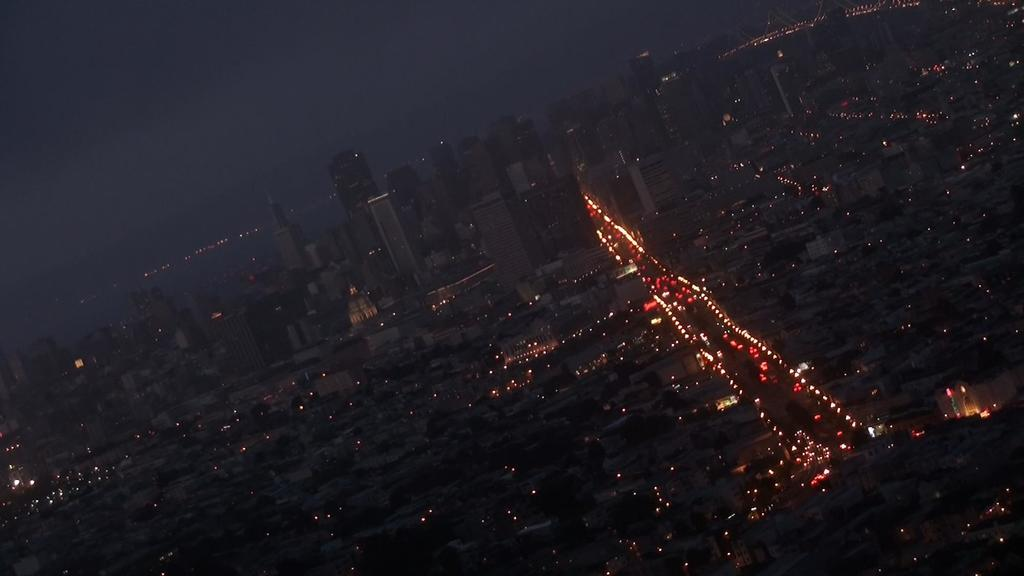What type of structures can be seen in the image? There are buildings in the image. What else can be observed in the image besides the buildings? There are lights visible in the image. How many cakes are stacked on top of the boot in the image? There are no cakes or boots present in the image. 